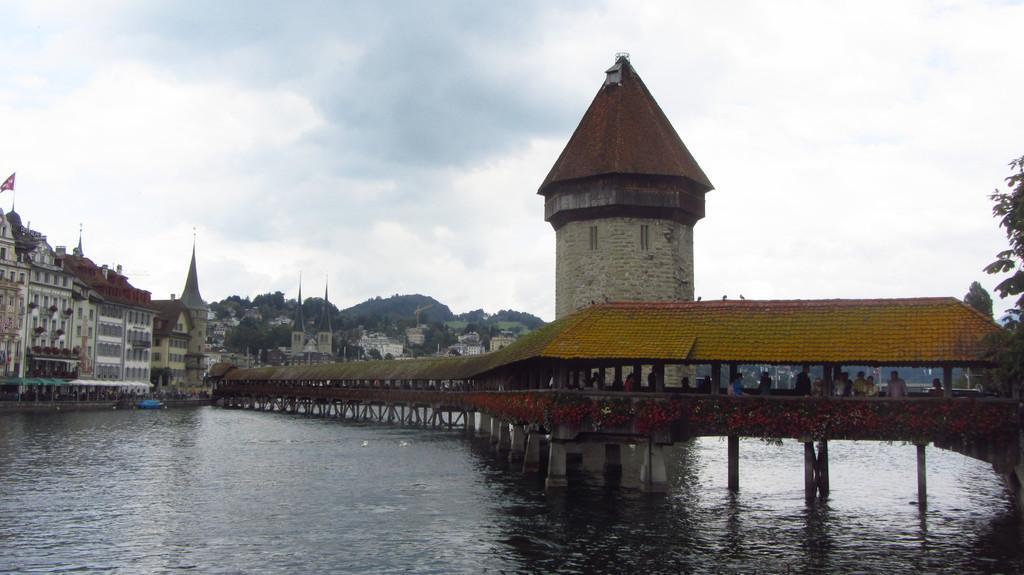Could you give a brief overview of what you see in this image? In the image there is a lake in the front with a bridge over it and many people walking on it, in the back there are many buildings all over the place with trees in the middle of it and above its sky with clouds. 